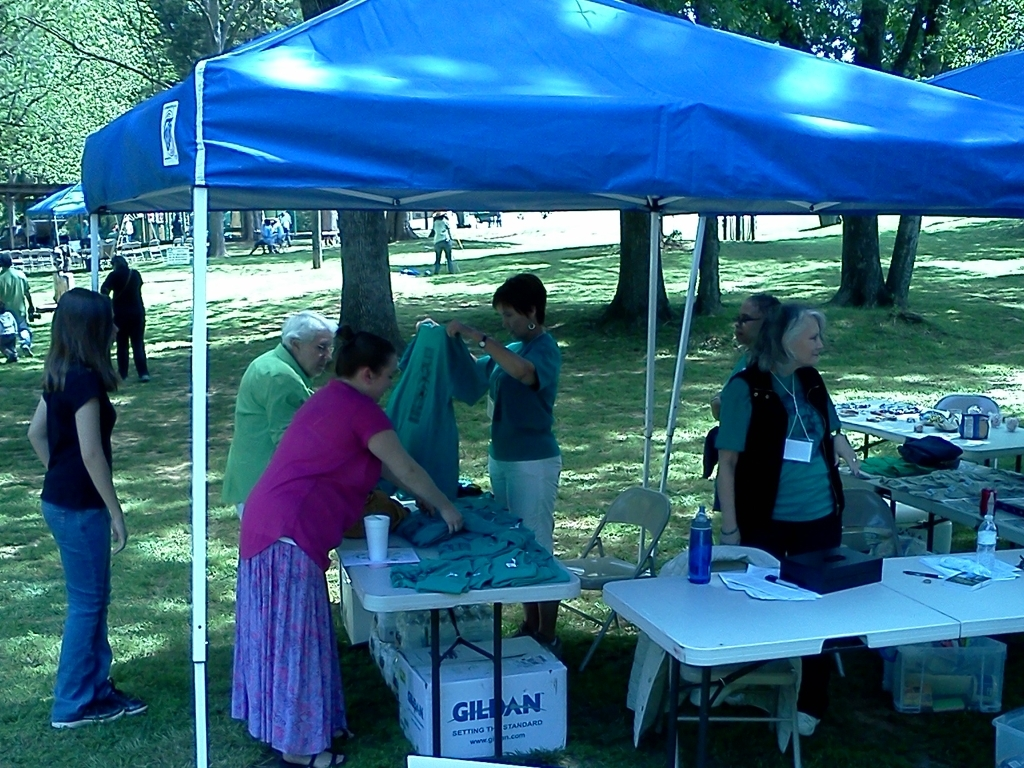How would you rate the quality of this image?
A. Average
B. Good
C. Poor
D. Excellent
Answer with the option's letter from the given choices directly. The quality of the image can be considered 'Good' (Option B), as it is relatively clear and the subjects are discernible. However, it has scope for improvement, such as better lighting and composition to elevate its quality further. 